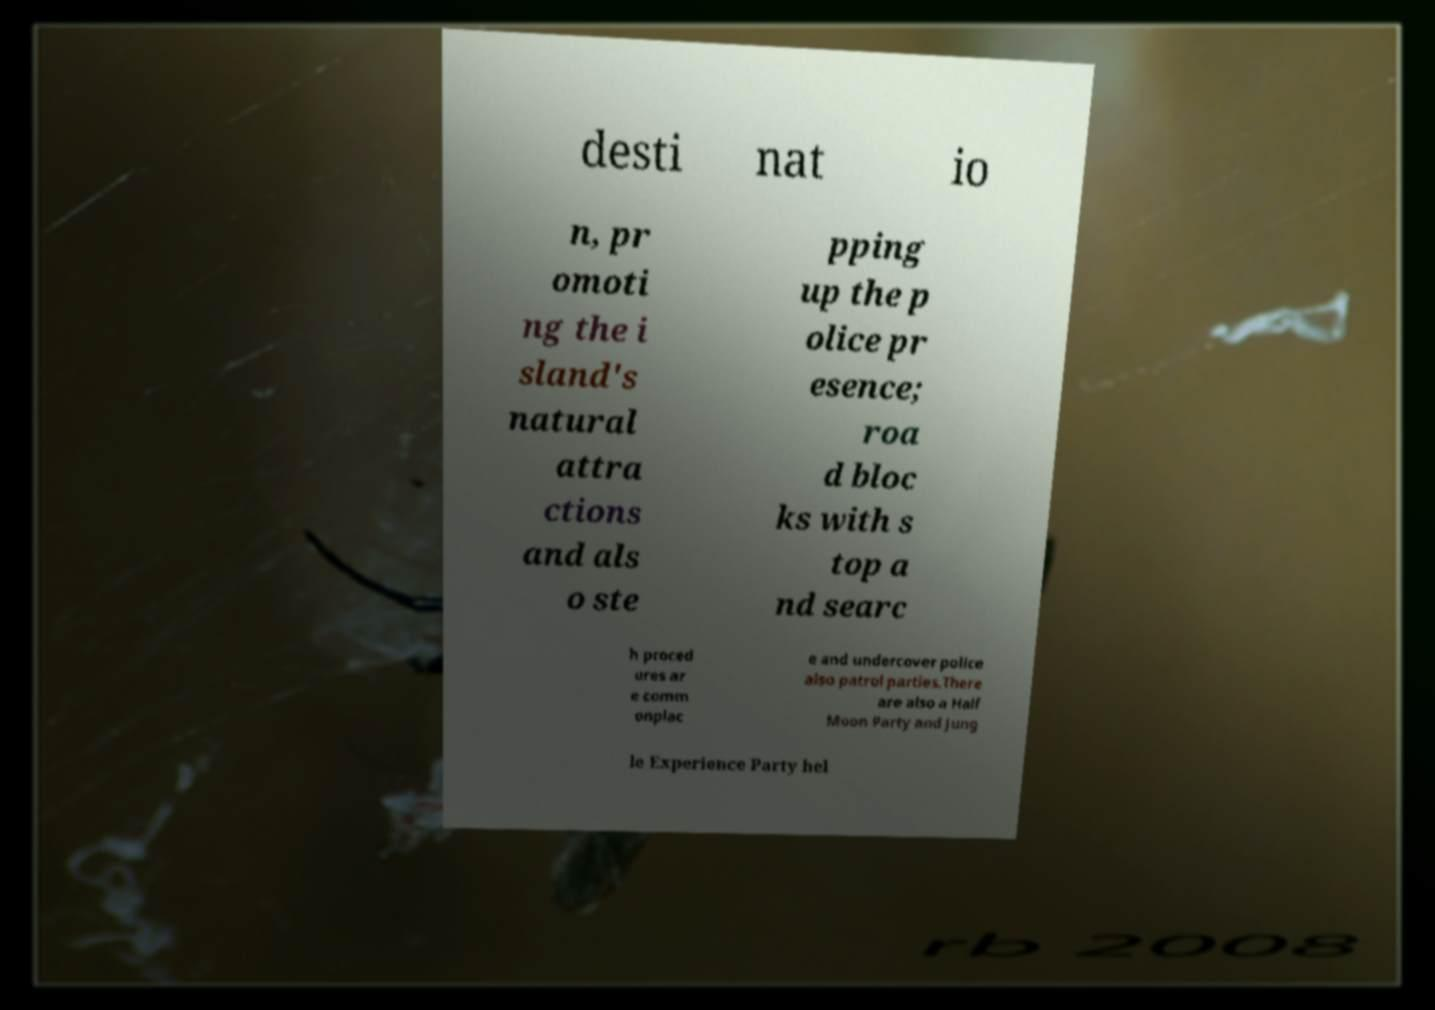Could you assist in decoding the text presented in this image and type it out clearly? desti nat io n, pr omoti ng the i sland's natural attra ctions and als o ste pping up the p olice pr esence; roa d bloc ks with s top a nd searc h proced ures ar e comm onplac e and undercover police also patrol parties.There are also a Half Moon Party and Jung le Experience Party hel 